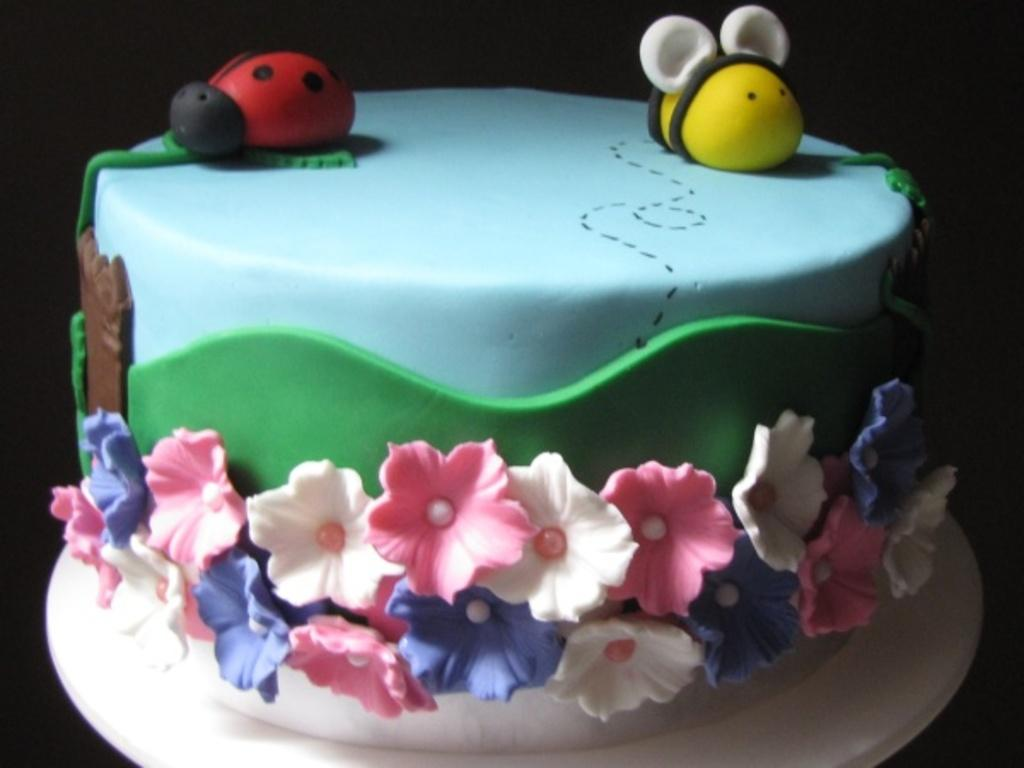How many colors can be seen on the cake in the image? The cake has multiple colors, including red, black, yellow, white, brown, blue, green, pink, and purple. What is the color of the background in the image? The background of the image is black. Can you see any pears on the cake in the image? There are no pears visible on the cake in the image. What type of pest can be seen crawling on the pan in the image? There is no pan or pest present in the image. 